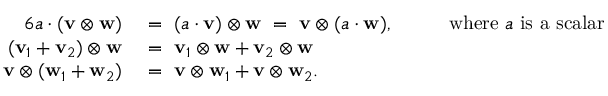Convert formula to latex. <formula><loc_0><loc_0><loc_500><loc_500>{ \begin{array} { r l r l } { { 6 } a \cdot ( v \otimes w ) } & { = ( a \cdot v ) \otimes w = v \otimes ( a \cdot w ) , } & & { { w h e r e } a { i s a s c a l a r } } \\ { ( v _ { 1 } + v _ { 2 } ) \otimes w } & { = v _ { 1 } \otimes w + v _ { 2 } \otimes w } & \\ { v \otimes ( w _ { 1 } + w _ { 2 } ) } & { = v \otimes w _ { 1 } + v \otimes w _ { 2 } . } & \end{array} }</formula> 